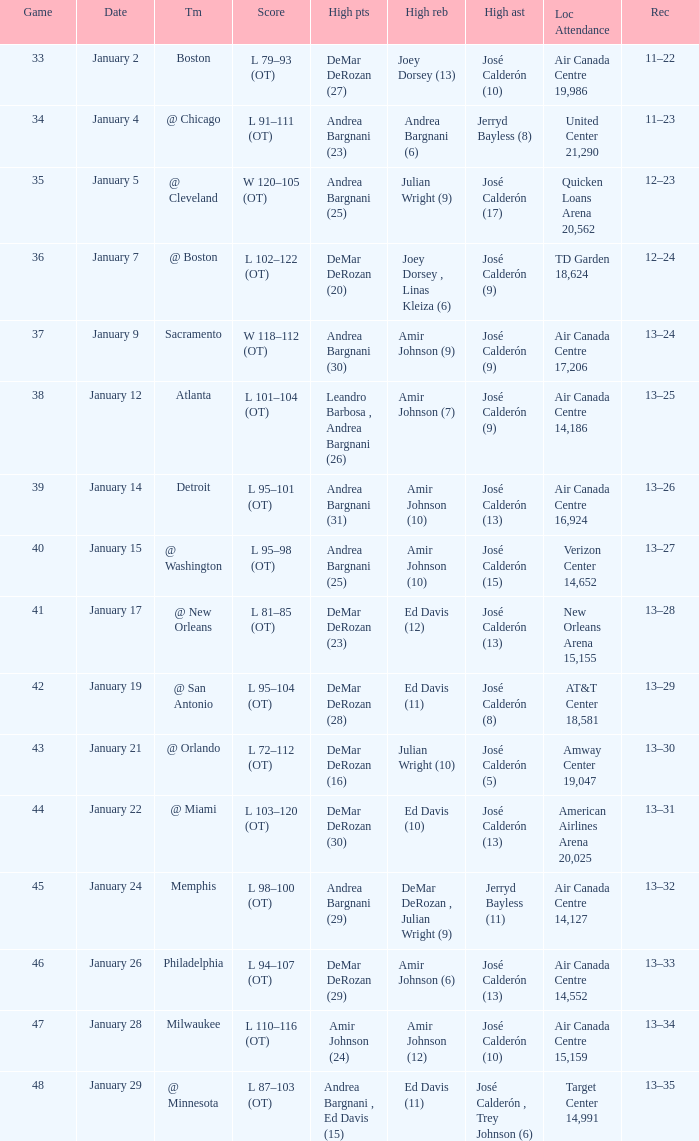I'm looking to parse the entire table for insights. Could you assist me with that? {'header': ['Game', 'Date', 'Tm', 'Score', 'High pts', 'High reb', 'High ast', 'Loc Attendance', 'Rec'], 'rows': [['33', 'January 2', 'Boston', 'L 79–93 (OT)', 'DeMar DeRozan (27)', 'Joey Dorsey (13)', 'José Calderón (10)', 'Air Canada Centre 19,986', '11–22'], ['34', 'January 4', '@ Chicago', 'L 91–111 (OT)', 'Andrea Bargnani (23)', 'Andrea Bargnani (6)', 'Jerryd Bayless (8)', 'United Center 21,290', '11–23'], ['35', 'January 5', '@ Cleveland', 'W 120–105 (OT)', 'Andrea Bargnani (25)', 'Julian Wright (9)', 'José Calderón (17)', 'Quicken Loans Arena 20,562', '12–23'], ['36', 'January 7', '@ Boston', 'L 102–122 (OT)', 'DeMar DeRozan (20)', 'Joey Dorsey , Linas Kleiza (6)', 'José Calderón (9)', 'TD Garden 18,624', '12–24'], ['37', 'January 9', 'Sacramento', 'W 118–112 (OT)', 'Andrea Bargnani (30)', 'Amir Johnson (9)', 'José Calderón (9)', 'Air Canada Centre 17,206', '13–24'], ['38', 'January 12', 'Atlanta', 'L 101–104 (OT)', 'Leandro Barbosa , Andrea Bargnani (26)', 'Amir Johnson (7)', 'José Calderón (9)', 'Air Canada Centre 14,186', '13–25'], ['39', 'January 14', 'Detroit', 'L 95–101 (OT)', 'Andrea Bargnani (31)', 'Amir Johnson (10)', 'José Calderón (13)', 'Air Canada Centre 16,924', '13–26'], ['40', 'January 15', '@ Washington', 'L 95–98 (OT)', 'Andrea Bargnani (25)', 'Amir Johnson (10)', 'José Calderón (15)', 'Verizon Center 14,652', '13–27'], ['41', 'January 17', '@ New Orleans', 'L 81–85 (OT)', 'DeMar DeRozan (23)', 'Ed Davis (12)', 'José Calderón (13)', 'New Orleans Arena 15,155', '13–28'], ['42', 'January 19', '@ San Antonio', 'L 95–104 (OT)', 'DeMar DeRozan (28)', 'Ed Davis (11)', 'José Calderón (8)', 'AT&T Center 18,581', '13–29'], ['43', 'January 21', '@ Orlando', 'L 72–112 (OT)', 'DeMar DeRozan (16)', 'Julian Wright (10)', 'José Calderón (5)', 'Amway Center 19,047', '13–30'], ['44', 'January 22', '@ Miami', 'L 103–120 (OT)', 'DeMar DeRozan (30)', 'Ed Davis (10)', 'José Calderón (13)', 'American Airlines Arena 20,025', '13–31'], ['45', 'January 24', 'Memphis', 'L 98–100 (OT)', 'Andrea Bargnani (29)', 'DeMar DeRozan , Julian Wright (9)', 'Jerryd Bayless (11)', 'Air Canada Centre 14,127', '13–32'], ['46', 'January 26', 'Philadelphia', 'L 94–107 (OT)', 'DeMar DeRozan (29)', 'Amir Johnson (6)', 'José Calderón (13)', 'Air Canada Centre 14,552', '13–33'], ['47', 'January 28', 'Milwaukee', 'L 110–116 (OT)', 'Amir Johnson (24)', 'Amir Johnson (12)', 'José Calderón (10)', 'Air Canada Centre 15,159', '13–34'], ['48', 'January 29', '@ Minnesota', 'L 87–103 (OT)', 'Andrea Bargnani , Ed Davis (15)', 'Ed Davis (11)', 'José Calderón , Trey Johnson (6)', 'Target Center 14,991', '13–35']]} Name the team for january 17 @ New Orleans. 